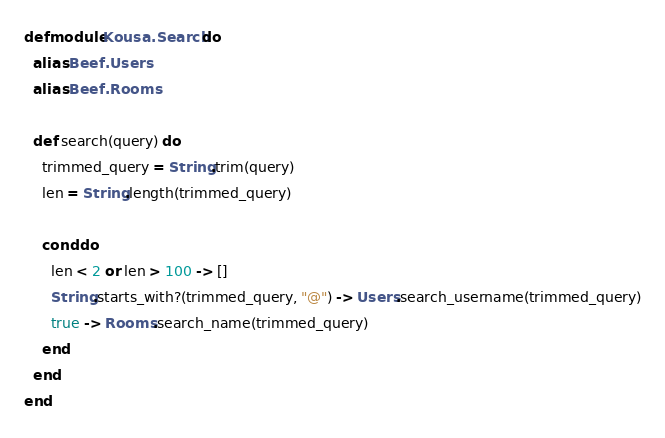Convert code to text. <code><loc_0><loc_0><loc_500><loc_500><_Elixir_>defmodule Kousa.Search do
  alias Beef.Users
  alias Beef.Rooms

  def search(query) do
    trimmed_query = String.trim(query)
    len = String.length(trimmed_query)

    cond do
      len < 2 or len > 100 -> []
      String.starts_with?(trimmed_query, "@") -> Users.search_username(trimmed_query)
      true -> Rooms.search_name(trimmed_query)
    end
  end
end
</code> 